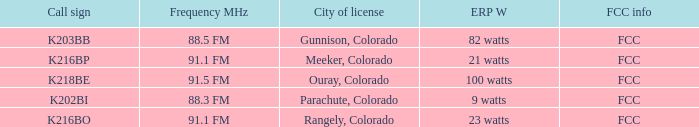Which fcc information possesses an erp w of 100 watts? FCC. 